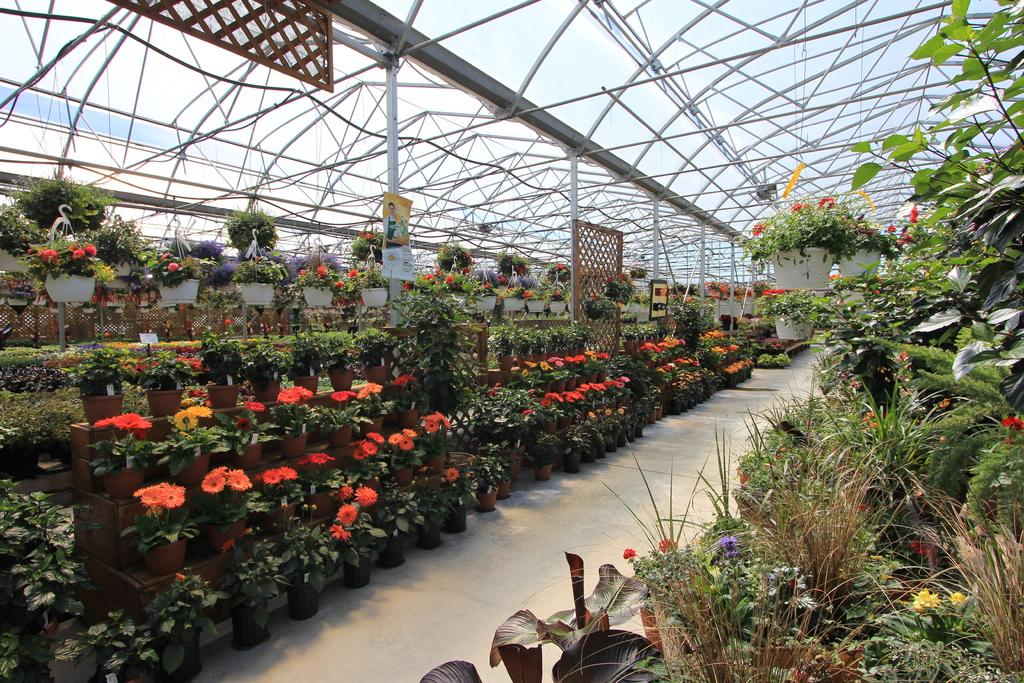What type of plants can be seen in the image? There are flower pot plants in the image. What material is present in the image that resembles a net or grid? There is mesh in the image. What type of structural elements are visible in the image? There are rods in the image. What type of wall decorations are present in the image? There are posters in the image. What other unspecified objects are present in the image? There are unspecified objects in the image. What type of rail can be seen in the image? There is no rail present in the image. What emotion does the disgusting whip evoke in the image? There is no whip or any indication of disgust present in the image. 